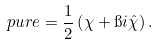<formula> <loc_0><loc_0><loc_500><loc_500>\ p u r e = \frac { 1 } { 2 } \left ( \chi + \i i \hat { \chi } \right ) .</formula> 